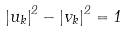<formula> <loc_0><loc_0><loc_500><loc_500>\left | u _ { k } \right | ^ { 2 } - \left | v _ { k } \right | ^ { 2 } = 1</formula> 